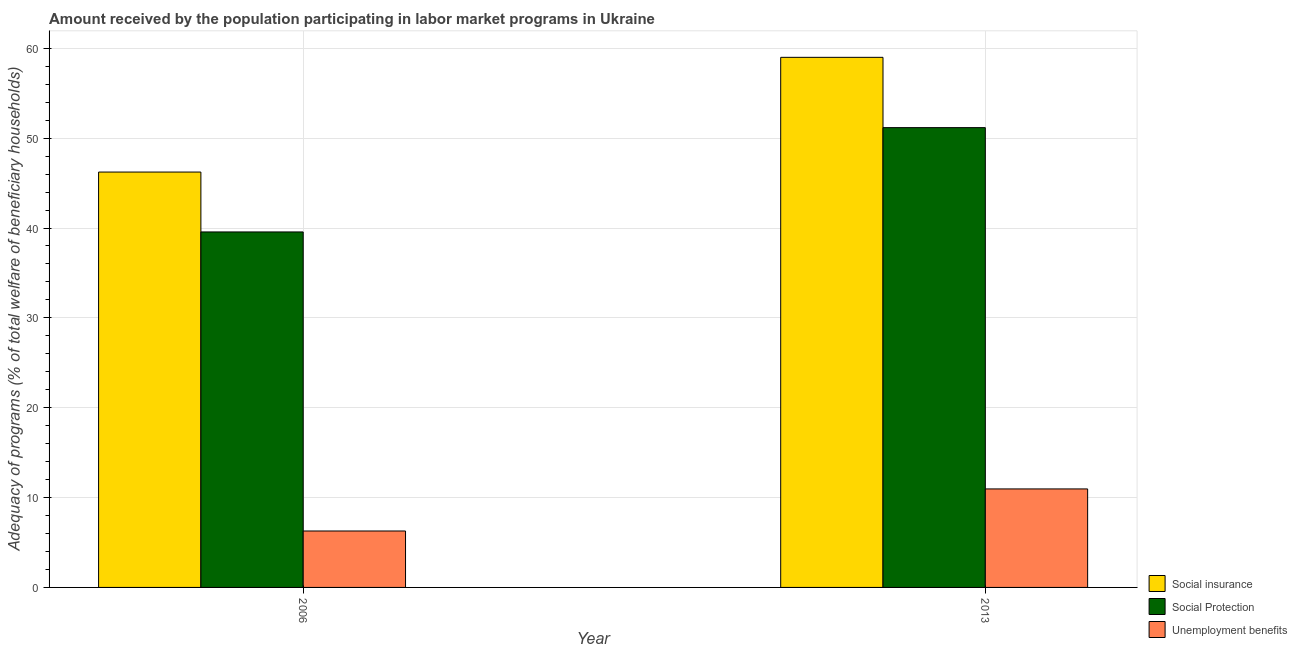How many different coloured bars are there?
Your answer should be compact. 3. Are the number of bars per tick equal to the number of legend labels?
Give a very brief answer. Yes. Are the number of bars on each tick of the X-axis equal?
Provide a succinct answer. Yes. How many bars are there on the 1st tick from the left?
Make the answer very short. 3. What is the amount received by the population participating in social insurance programs in 2006?
Your response must be concise. 46.23. Across all years, what is the maximum amount received by the population participating in unemployment benefits programs?
Give a very brief answer. 10.96. Across all years, what is the minimum amount received by the population participating in social protection programs?
Give a very brief answer. 39.56. What is the total amount received by the population participating in social insurance programs in the graph?
Keep it short and to the point. 105.22. What is the difference between the amount received by the population participating in unemployment benefits programs in 2006 and that in 2013?
Your response must be concise. -4.68. What is the difference between the amount received by the population participating in social protection programs in 2013 and the amount received by the population participating in unemployment benefits programs in 2006?
Make the answer very short. 11.61. What is the average amount received by the population participating in social insurance programs per year?
Provide a succinct answer. 52.61. In the year 2006, what is the difference between the amount received by the population participating in social insurance programs and amount received by the population participating in unemployment benefits programs?
Give a very brief answer. 0. In how many years, is the amount received by the population participating in social insurance programs greater than 42 %?
Your answer should be compact. 2. What is the ratio of the amount received by the population participating in social protection programs in 2006 to that in 2013?
Make the answer very short. 0.77. Is the amount received by the population participating in unemployment benefits programs in 2006 less than that in 2013?
Give a very brief answer. Yes. What does the 3rd bar from the left in 2013 represents?
Provide a succinct answer. Unemployment benefits. What does the 2nd bar from the right in 2006 represents?
Offer a terse response. Social Protection. How many bars are there?
Provide a short and direct response. 6. What is the difference between two consecutive major ticks on the Y-axis?
Ensure brevity in your answer.  10. What is the title of the graph?
Give a very brief answer. Amount received by the population participating in labor market programs in Ukraine. Does "Fuel" appear as one of the legend labels in the graph?
Offer a very short reply. No. What is the label or title of the X-axis?
Make the answer very short. Year. What is the label or title of the Y-axis?
Offer a terse response. Adequacy of programs (% of total welfare of beneficiary households). What is the Adequacy of programs (% of total welfare of beneficiary households) in Social insurance in 2006?
Offer a very short reply. 46.23. What is the Adequacy of programs (% of total welfare of beneficiary households) of Social Protection in 2006?
Ensure brevity in your answer.  39.56. What is the Adequacy of programs (% of total welfare of beneficiary households) of Unemployment benefits in 2006?
Keep it short and to the point. 6.28. What is the Adequacy of programs (% of total welfare of beneficiary households) in Social insurance in 2013?
Your answer should be compact. 58.99. What is the Adequacy of programs (% of total welfare of beneficiary households) in Social Protection in 2013?
Make the answer very short. 51.17. What is the Adequacy of programs (% of total welfare of beneficiary households) in Unemployment benefits in 2013?
Provide a succinct answer. 10.96. Across all years, what is the maximum Adequacy of programs (% of total welfare of beneficiary households) in Social insurance?
Ensure brevity in your answer.  58.99. Across all years, what is the maximum Adequacy of programs (% of total welfare of beneficiary households) of Social Protection?
Make the answer very short. 51.17. Across all years, what is the maximum Adequacy of programs (% of total welfare of beneficiary households) in Unemployment benefits?
Make the answer very short. 10.96. Across all years, what is the minimum Adequacy of programs (% of total welfare of beneficiary households) of Social insurance?
Provide a short and direct response. 46.23. Across all years, what is the minimum Adequacy of programs (% of total welfare of beneficiary households) of Social Protection?
Ensure brevity in your answer.  39.56. Across all years, what is the minimum Adequacy of programs (% of total welfare of beneficiary households) in Unemployment benefits?
Offer a very short reply. 6.28. What is the total Adequacy of programs (% of total welfare of beneficiary households) of Social insurance in the graph?
Your answer should be compact. 105.22. What is the total Adequacy of programs (% of total welfare of beneficiary households) of Social Protection in the graph?
Offer a very short reply. 90.73. What is the total Adequacy of programs (% of total welfare of beneficiary households) of Unemployment benefits in the graph?
Provide a succinct answer. 17.24. What is the difference between the Adequacy of programs (% of total welfare of beneficiary households) in Social insurance in 2006 and that in 2013?
Your response must be concise. -12.77. What is the difference between the Adequacy of programs (% of total welfare of beneficiary households) of Social Protection in 2006 and that in 2013?
Your answer should be compact. -11.61. What is the difference between the Adequacy of programs (% of total welfare of beneficiary households) of Unemployment benefits in 2006 and that in 2013?
Your response must be concise. -4.68. What is the difference between the Adequacy of programs (% of total welfare of beneficiary households) of Social insurance in 2006 and the Adequacy of programs (% of total welfare of beneficiary households) of Social Protection in 2013?
Provide a succinct answer. -4.94. What is the difference between the Adequacy of programs (% of total welfare of beneficiary households) of Social insurance in 2006 and the Adequacy of programs (% of total welfare of beneficiary households) of Unemployment benefits in 2013?
Offer a very short reply. 35.26. What is the difference between the Adequacy of programs (% of total welfare of beneficiary households) of Social Protection in 2006 and the Adequacy of programs (% of total welfare of beneficiary households) of Unemployment benefits in 2013?
Your answer should be very brief. 28.6. What is the average Adequacy of programs (% of total welfare of beneficiary households) in Social insurance per year?
Your answer should be very brief. 52.61. What is the average Adequacy of programs (% of total welfare of beneficiary households) in Social Protection per year?
Keep it short and to the point. 45.37. What is the average Adequacy of programs (% of total welfare of beneficiary households) of Unemployment benefits per year?
Your response must be concise. 8.62. In the year 2006, what is the difference between the Adequacy of programs (% of total welfare of beneficiary households) in Social insurance and Adequacy of programs (% of total welfare of beneficiary households) in Social Protection?
Provide a short and direct response. 6.66. In the year 2006, what is the difference between the Adequacy of programs (% of total welfare of beneficiary households) of Social insurance and Adequacy of programs (% of total welfare of beneficiary households) of Unemployment benefits?
Your answer should be compact. 39.95. In the year 2006, what is the difference between the Adequacy of programs (% of total welfare of beneficiary households) in Social Protection and Adequacy of programs (% of total welfare of beneficiary households) in Unemployment benefits?
Make the answer very short. 33.28. In the year 2013, what is the difference between the Adequacy of programs (% of total welfare of beneficiary households) in Social insurance and Adequacy of programs (% of total welfare of beneficiary households) in Social Protection?
Provide a short and direct response. 7.82. In the year 2013, what is the difference between the Adequacy of programs (% of total welfare of beneficiary households) in Social insurance and Adequacy of programs (% of total welfare of beneficiary households) in Unemployment benefits?
Offer a terse response. 48.03. In the year 2013, what is the difference between the Adequacy of programs (% of total welfare of beneficiary households) of Social Protection and Adequacy of programs (% of total welfare of beneficiary households) of Unemployment benefits?
Provide a succinct answer. 40.21. What is the ratio of the Adequacy of programs (% of total welfare of beneficiary households) of Social insurance in 2006 to that in 2013?
Provide a short and direct response. 0.78. What is the ratio of the Adequacy of programs (% of total welfare of beneficiary households) of Social Protection in 2006 to that in 2013?
Your response must be concise. 0.77. What is the ratio of the Adequacy of programs (% of total welfare of beneficiary households) in Unemployment benefits in 2006 to that in 2013?
Provide a succinct answer. 0.57. What is the difference between the highest and the second highest Adequacy of programs (% of total welfare of beneficiary households) in Social insurance?
Your response must be concise. 12.77. What is the difference between the highest and the second highest Adequacy of programs (% of total welfare of beneficiary households) in Social Protection?
Ensure brevity in your answer.  11.61. What is the difference between the highest and the second highest Adequacy of programs (% of total welfare of beneficiary households) in Unemployment benefits?
Provide a short and direct response. 4.68. What is the difference between the highest and the lowest Adequacy of programs (% of total welfare of beneficiary households) in Social insurance?
Your answer should be very brief. 12.77. What is the difference between the highest and the lowest Adequacy of programs (% of total welfare of beneficiary households) of Social Protection?
Offer a very short reply. 11.61. What is the difference between the highest and the lowest Adequacy of programs (% of total welfare of beneficiary households) in Unemployment benefits?
Give a very brief answer. 4.68. 